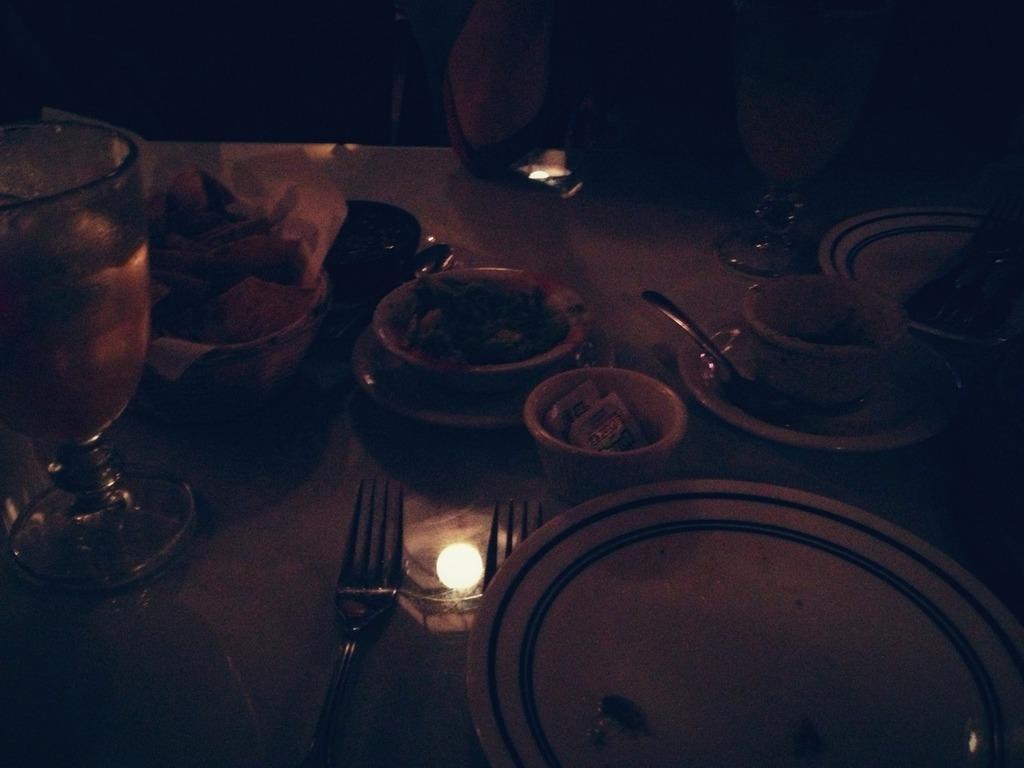Please provide a concise description of this image. This image consists of a dining table. On which there are many bowls and plates along with forks. On the left, we can see a wine glass. In the middle, there is a light. In the front, it looks like a person sitting. 